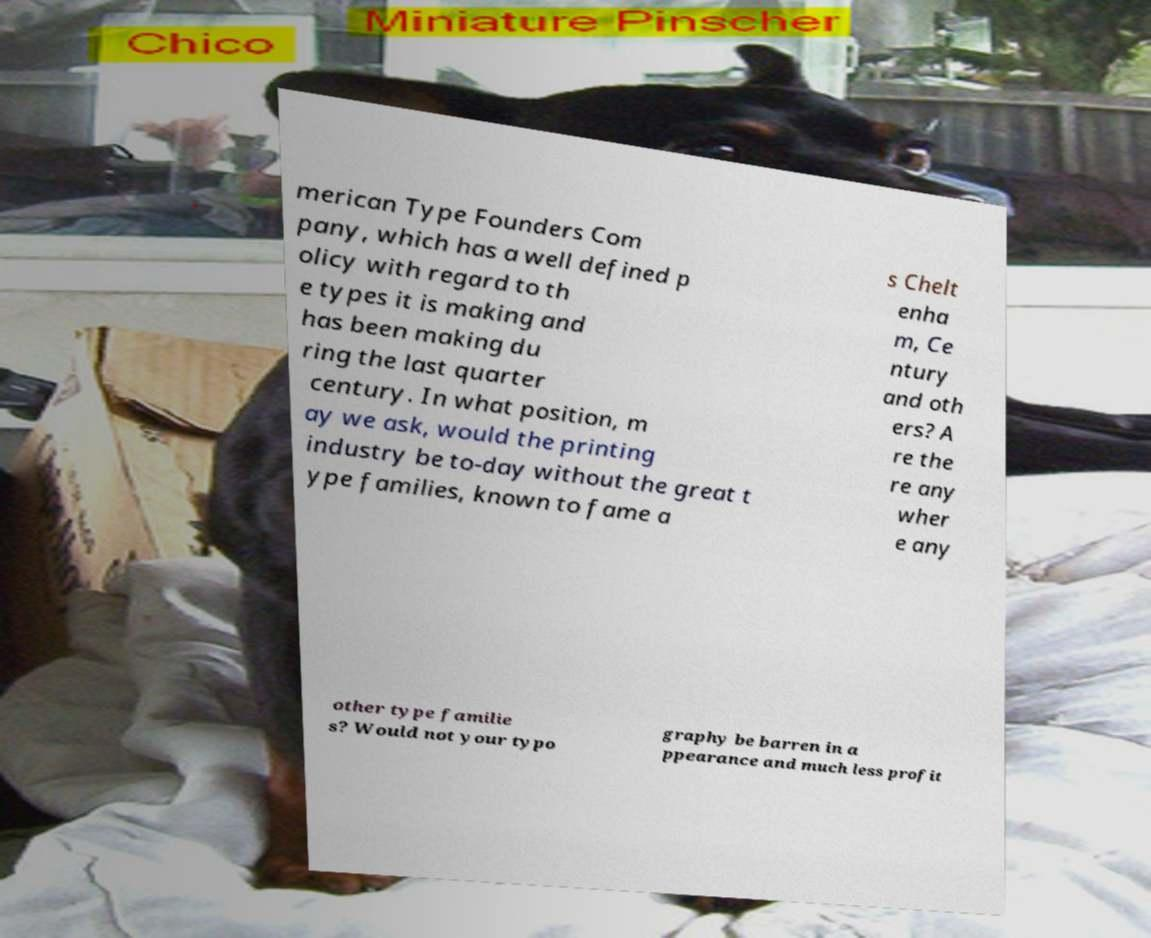Can you read and provide the text displayed in the image?This photo seems to have some interesting text. Can you extract and type it out for me? merican Type Founders Com pany, which has a well defined p olicy with regard to th e types it is making and has been making du ring the last quarter century. In what position, m ay we ask, would the printing industry be to-day without the great t ype families, known to fame a s Chelt enha m, Ce ntury and oth ers? A re the re any wher e any other type familie s? Would not your typo graphy be barren in a ppearance and much less profit 